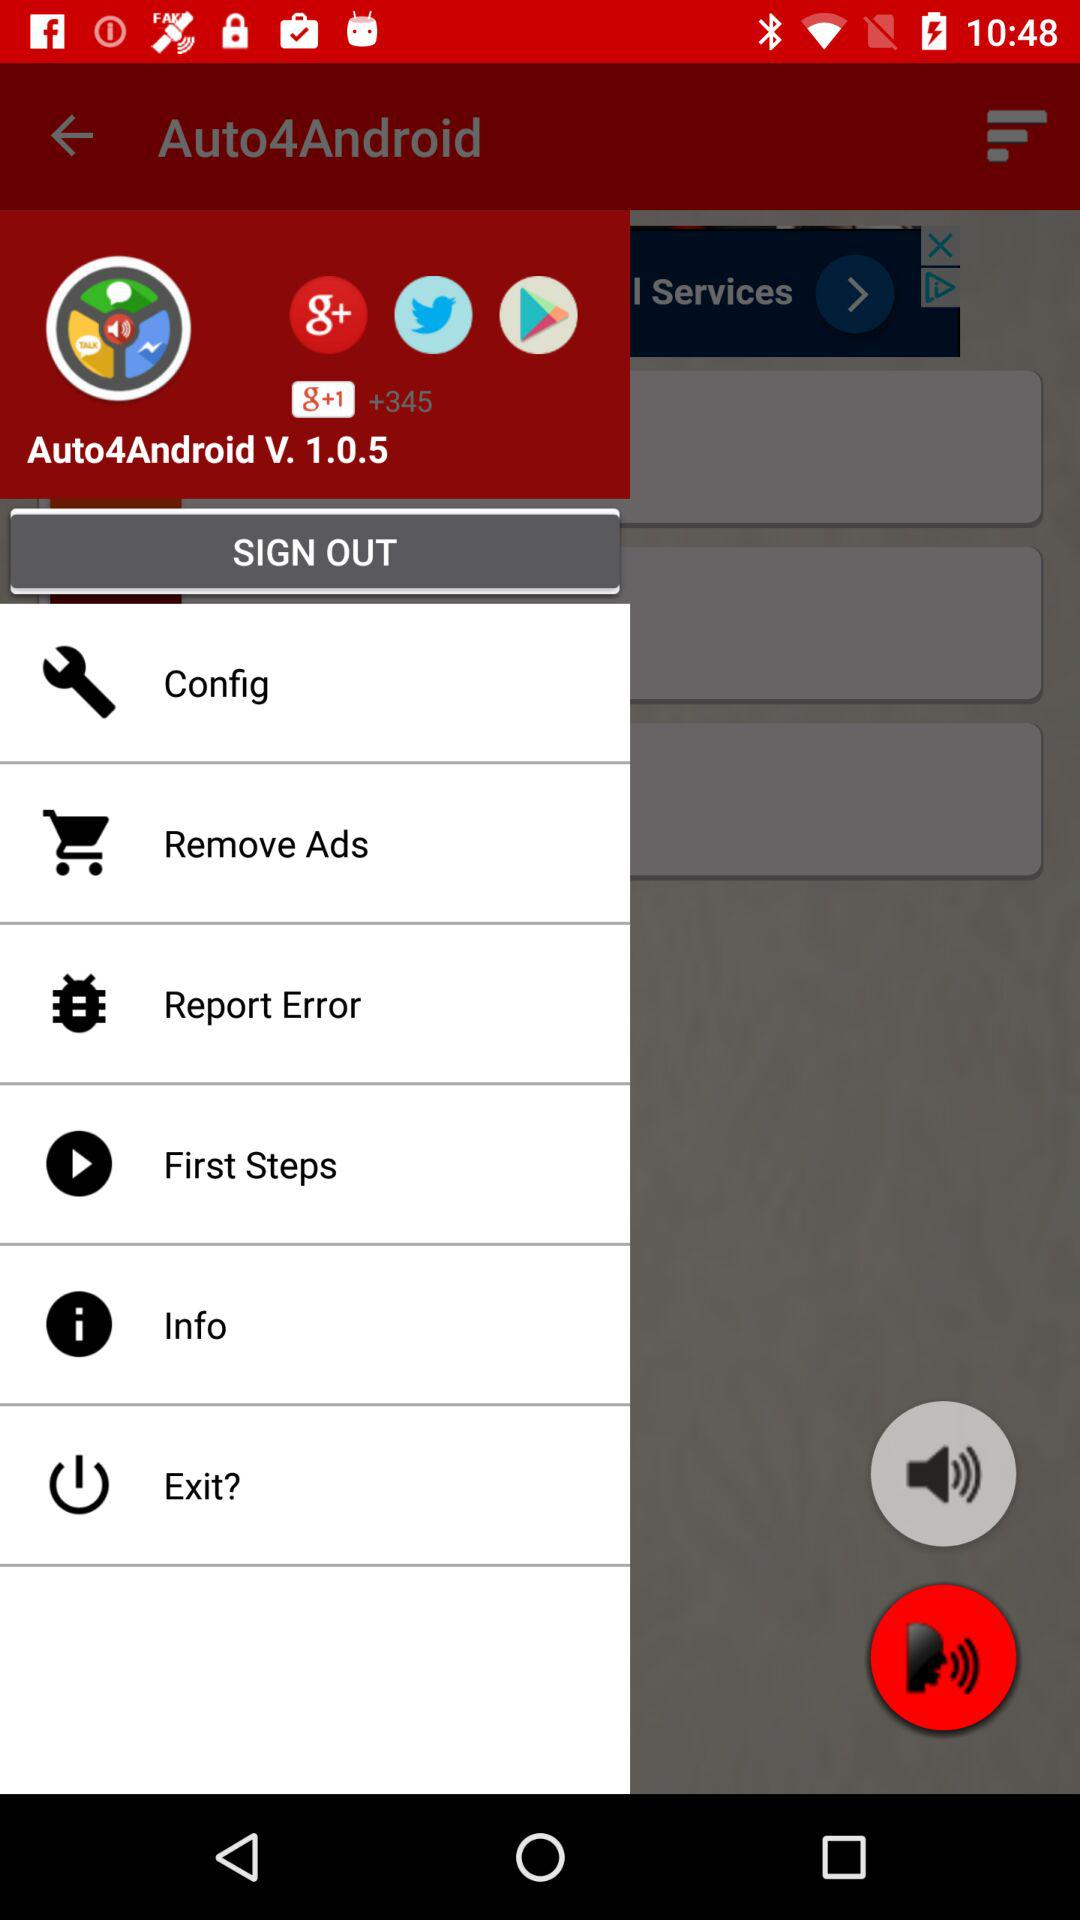How many menu items are there?
Answer the question using a single word or phrase. 6 